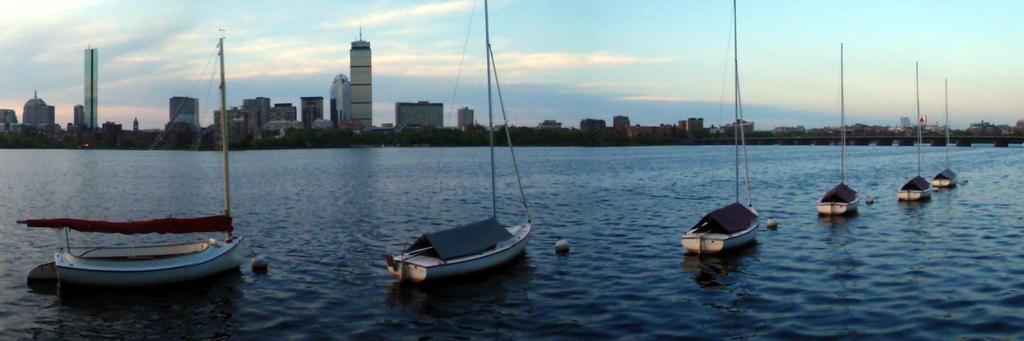How would you summarize this image in a sentence or two? In this image we can see some boats with poles and ropes in a large water body. On the backside we can see a bridge, a group of buildings and the sky which looks cloudy. 